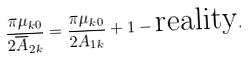Convert formula to latex. <formula><loc_0><loc_0><loc_500><loc_500>\frac { \pi \mu _ { k 0 } } { 2 \overline { A } _ { 2 k } } = \frac { \pi \mu _ { k 0 } } { 2 A _ { 1 k } } + 1 - \text {reality} .</formula> 